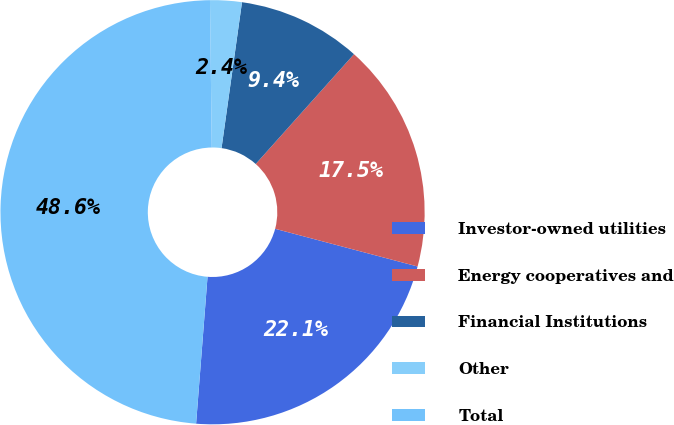<chart> <loc_0><loc_0><loc_500><loc_500><pie_chart><fcel>Investor-owned utilities<fcel>Energy cooperatives and<fcel>Financial Institutions<fcel>Other<fcel>Total<nl><fcel>22.12%<fcel>17.5%<fcel>9.4%<fcel>2.41%<fcel>48.57%<nl></chart> 